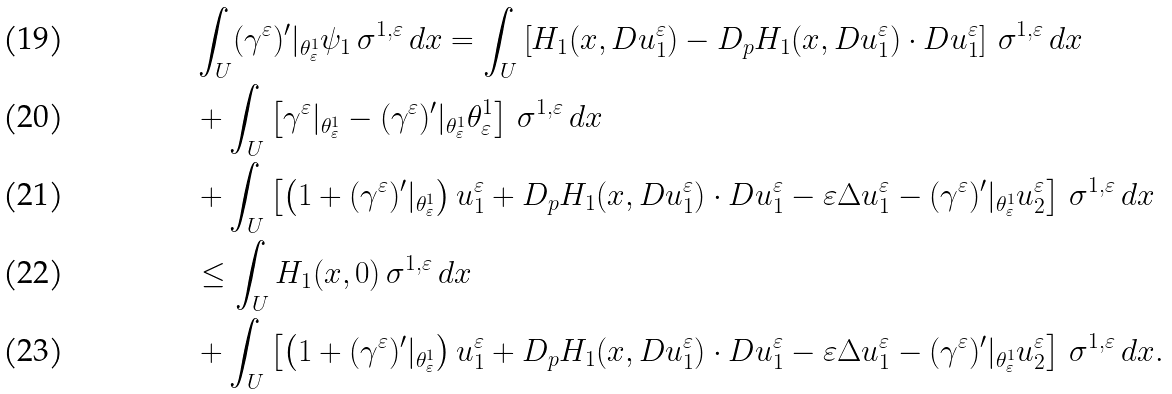Convert formula to latex. <formula><loc_0><loc_0><loc_500><loc_500>& \int _ { U } ( \gamma ^ { \varepsilon } ) ^ { \prime } | _ { \theta ^ { 1 } _ { \varepsilon } } \psi _ { 1 } \, \sigma ^ { 1 , \varepsilon } \, d x = \int _ { U } \left [ H _ { 1 } ( x , D u ^ { \varepsilon } _ { 1 } ) - D _ { p } H _ { 1 } ( x , D u ^ { \varepsilon } _ { 1 } ) \cdot D u ^ { \varepsilon } _ { 1 } \right ] \, \sigma ^ { 1 , \varepsilon } \, d x \\ & + \int _ { U } \left [ \gamma ^ { \varepsilon } | _ { \theta ^ { 1 } _ { \varepsilon } } - ( \gamma ^ { \varepsilon } ) ^ { \prime } | _ { \theta ^ { 1 } _ { \varepsilon } } \theta ^ { 1 } _ { \varepsilon } \right ] \, \sigma ^ { 1 , \varepsilon } \, d x \\ & + \int _ { U } \left [ \left ( 1 + ( \gamma ^ { \varepsilon } ) ^ { \prime } | _ { \theta ^ { 1 } _ { \varepsilon } } \right ) u ^ { \varepsilon } _ { 1 } + D _ { p } H _ { 1 } ( x , D u ^ { \varepsilon } _ { 1 } ) \cdot D u ^ { \varepsilon } _ { 1 } - \varepsilon \Delta u ^ { \varepsilon } _ { 1 } - ( \gamma ^ { \varepsilon } ) ^ { \prime } | _ { \theta ^ { 1 } _ { \varepsilon } } u _ { 2 } ^ { \varepsilon } \right ] \, \sigma ^ { 1 , \varepsilon } \, d x \\ & \leq \int _ { U } H _ { 1 } ( x , 0 ) \, \sigma ^ { 1 , \varepsilon } \, d x \\ & + \int _ { U } \left [ \left ( 1 + ( \gamma ^ { \varepsilon } ) ^ { \prime } | _ { \theta ^ { 1 } _ { \varepsilon } } \right ) u ^ { \varepsilon } _ { 1 } + D _ { p } H _ { 1 } ( x , D u ^ { \varepsilon } _ { 1 } ) \cdot D u ^ { \varepsilon } _ { 1 } - \varepsilon \Delta u ^ { \varepsilon } _ { 1 } - ( \gamma ^ { \varepsilon } ) ^ { \prime } | _ { \theta ^ { 1 } _ { \varepsilon } } u _ { 2 } ^ { \varepsilon } \right ] \, \sigma ^ { 1 , \varepsilon } \, d x .</formula> 